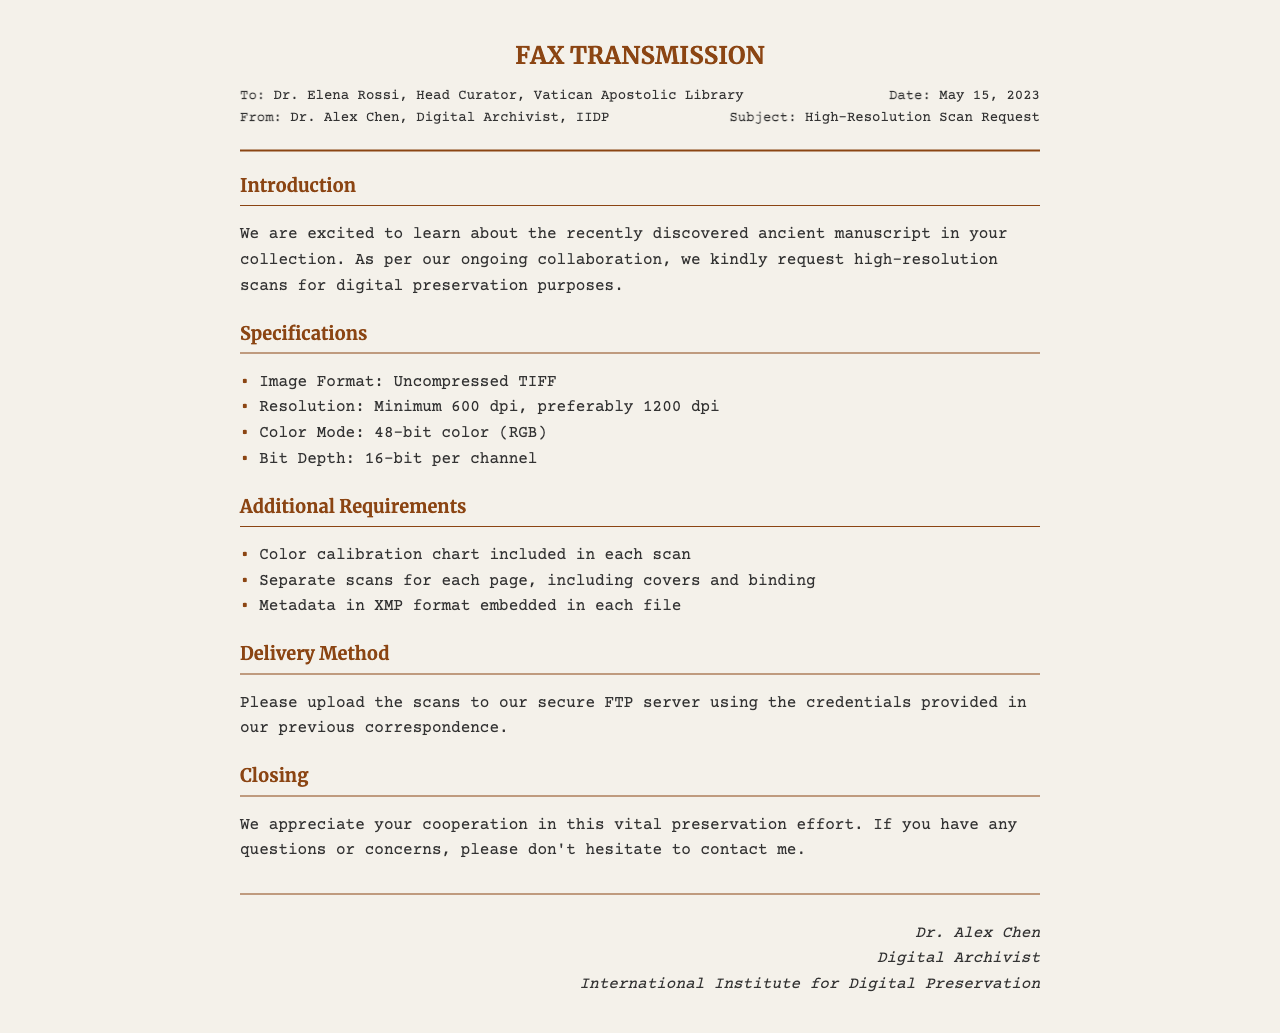What is the recipient's name? The recipient's name is indicated at the beginning of the fax, which states "Dr. Elena Rossi".
Answer: Dr. Elena Rossi What is the date of the fax? The date is found in the header section, specifically "May 15, 2023".
Answer: May 15, 2023 What is the minimum resolution specified? The document lists specifications including a minimum resolution of "600 dpi".
Answer: 600 dpi What color mode is requested? The color mode is specified in the section detailing specifications, which states "48-bit color (RGB)".
Answer: 48-bit color (RGB) What additional item must be included with each scan? The additional item is specified in the additional requirements section, which states "Color calibration chart".
Answer: Color calibration chart How should the scans be delivered? The delivery method described states to "upload the scans to our secure FTP server".
Answer: FTP server Who is the sender of the fax? The sender's information is provided in the header, stating "Dr. Alex Chen".
Answer: Dr. Alex Chen What format should the metadata be in? The additional requirements state that the metadata should be in "XMP format".
Answer: XMP format What organization is Dr. Alex Chen affiliated with? The closing section of the fax includes the affiliation "International Institute for Digital Preservation".
Answer: International Institute for Digital Preservation 